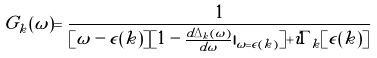<formula> <loc_0><loc_0><loc_500><loc_500>G _ { k } ( \omega ) = \frac { 1 } { [ \omega - \epsilon ( k ) ] [ 1 - \frac { d \Delta _ { k } ( \omega ) } { d \omega } | _ { \omega = \epsilon ( k ) } ] + i \Gamma _ { k } [ \epsilon ( k ) ] }</formula> 